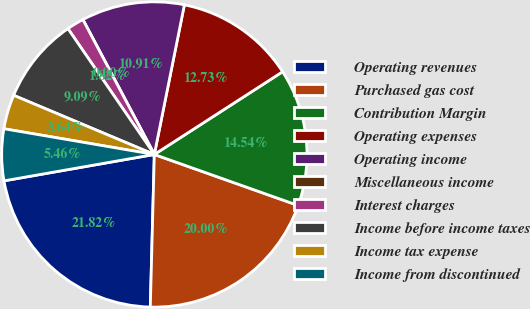Convert chart. <chart><loc_0><loc_0><loc_500><loc_500><pie_chart><fcel>Operating revenues<fcel>Purchased gas cost<fcel>Contribution Margin<fcel>Operating expenses<fcel>Operating income<fcel>Miscellaneous income<fcel>Interest charges<fcel>Income before income taxes<fcel>Income tax expense<fcel>Income from discontinued<nl><fcel>21.82%<fcel>20.0%<fcel>14.54%<fcel>12.73%<fcel>10.91%<fcel>0.0%<fcel>1.82%<fcel>9.09%<fcel>3.64%<fcel>5.46%<nl></chart> 